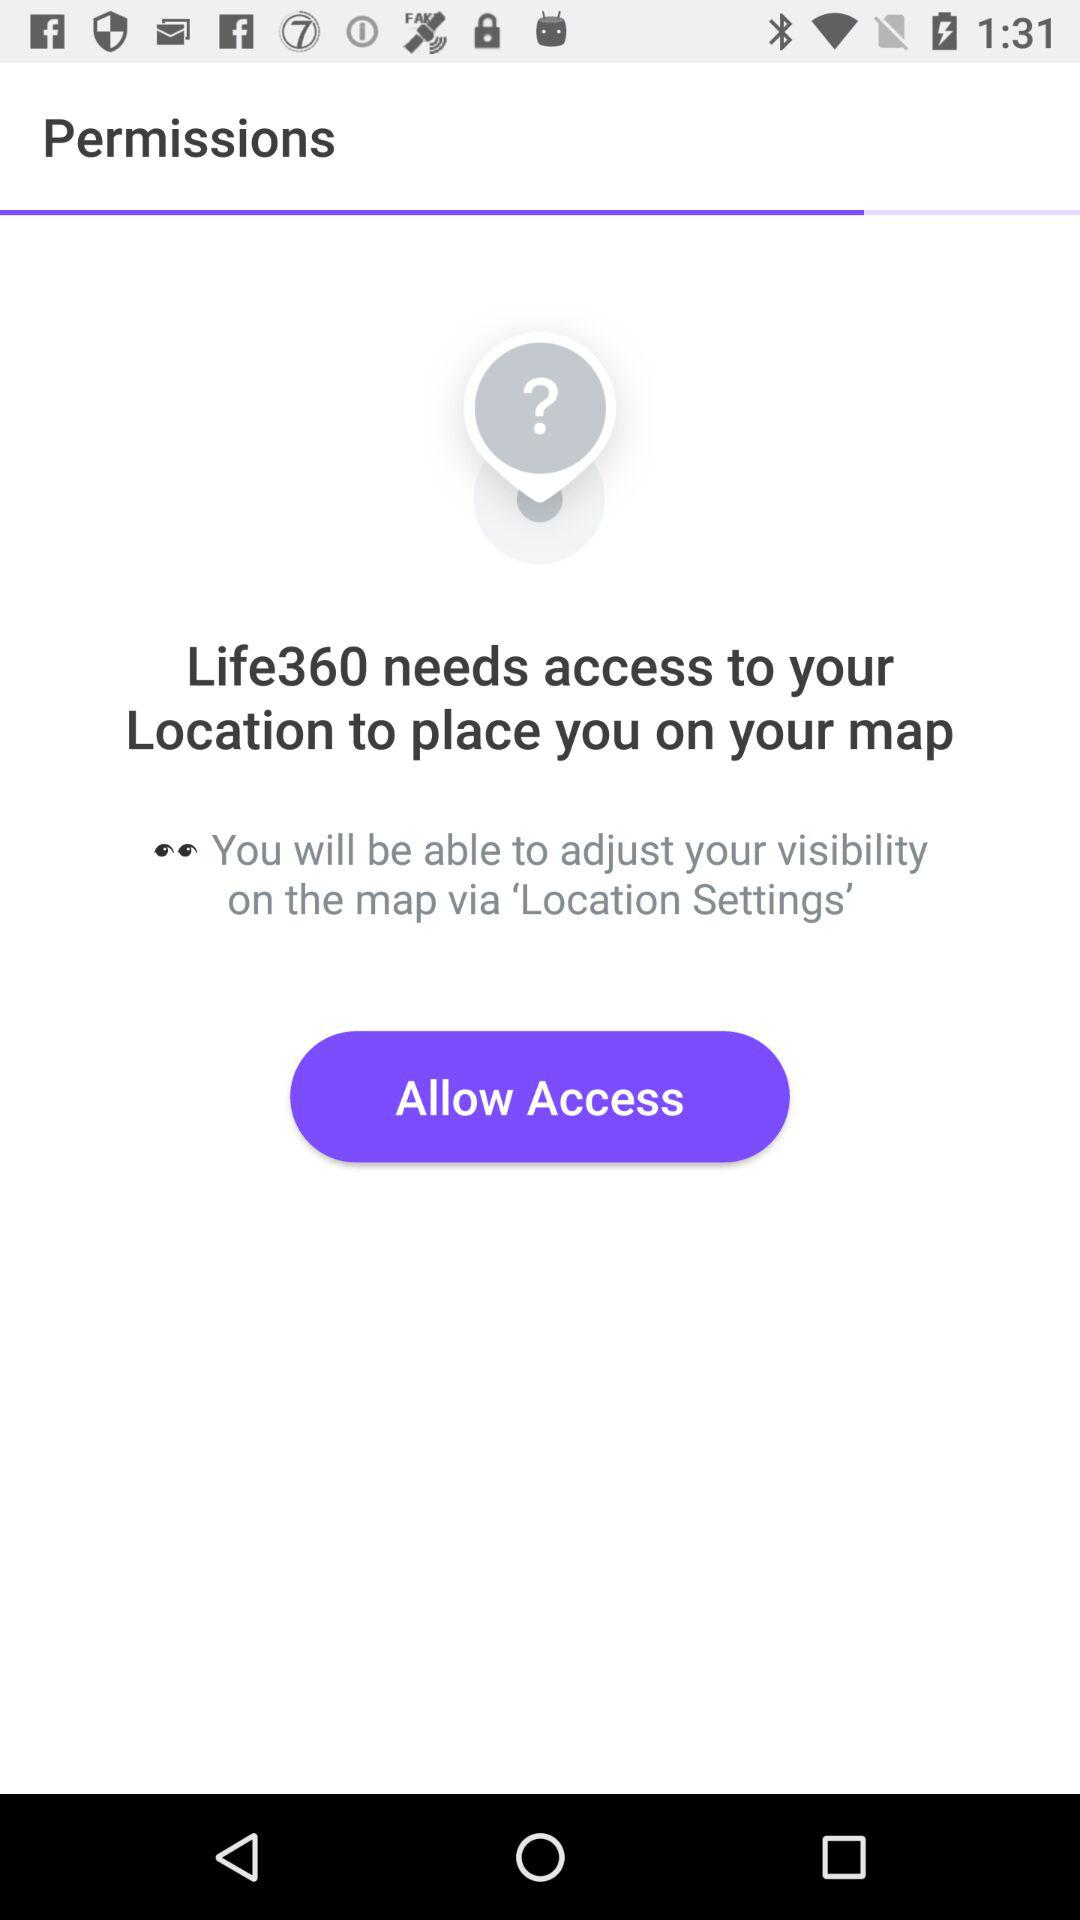What app is asking for access? The app asking for access is "Life360". 